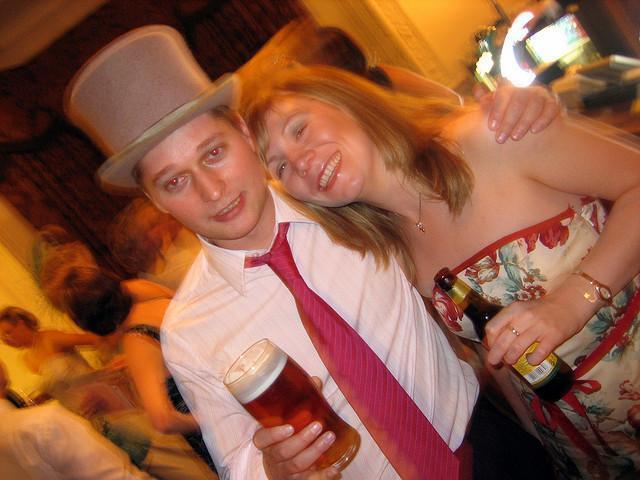How many people are visible?
Give a very brief answer. 8. How many cat does he have?
Give a very brief answer. 0. 